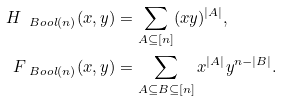Convert formula to latex. <formula><loc_0><loc_0><loc_500><loc_500>H _ { \ B o o l ( n ) } ( x , y ) & = \sum _ { A \subseteq [ n ] } ( x y ) ^ { | A | } , \\ F _ { \ B o o l ( n ) } ( x , y ) & = \sum _ { A \subseteq B \subseteq [ n ] } x ^ { | A | } y ^ { n - | B | } .</formula> 